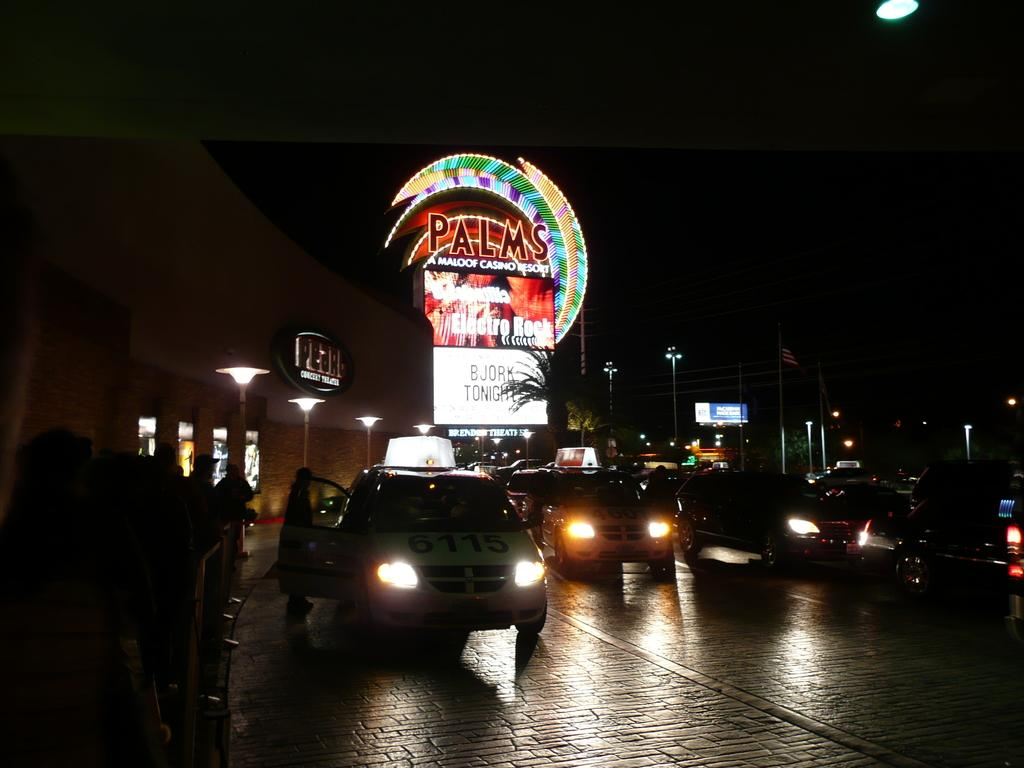<image>
Give a short and clear explanation of the subsequent image. Bjork is playing tonight at the Palms casino and resort. 